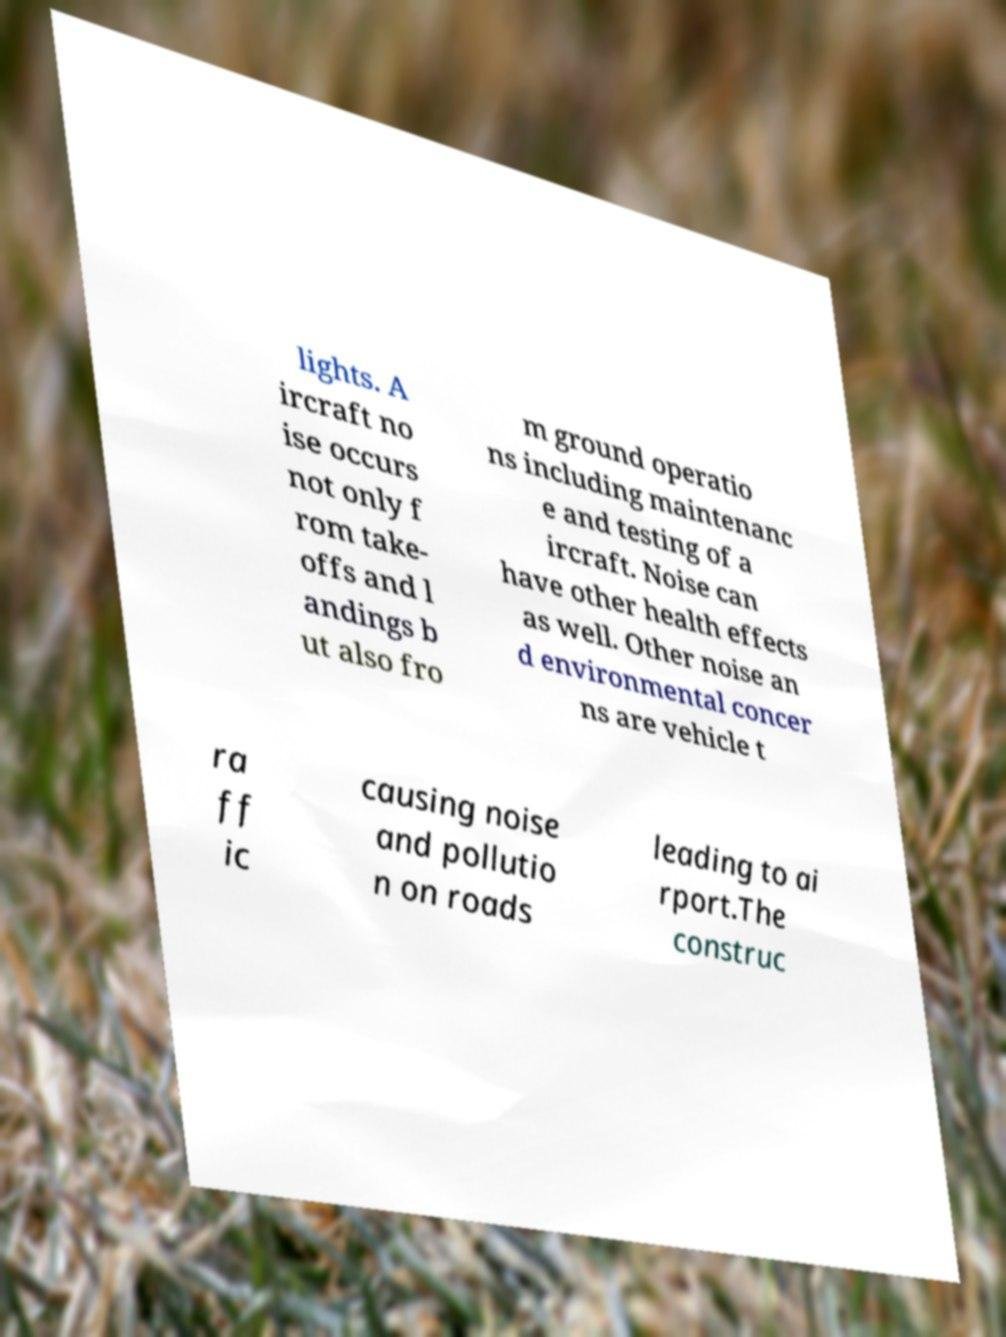For documentation purposes, I need the text within this image transcribed. Could you provide that? lights. A ircraft no ise occurs not only f rom take- offs and l andings b ut also fro m ground operatio ns including maintenanc e and testing of a ircraft. Noise can have other health effects as well. Other noise an d environmental concer ns are vehicle t ra ff ic causing noise and pollutio n on roads leading to ai rport.The construc 